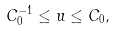<formula> <loc_0><loc_0><loc_500><loc_500>C _ { 0 } ^ { - 1 } \leq u \leq C _ { 0 } ,</formula> 